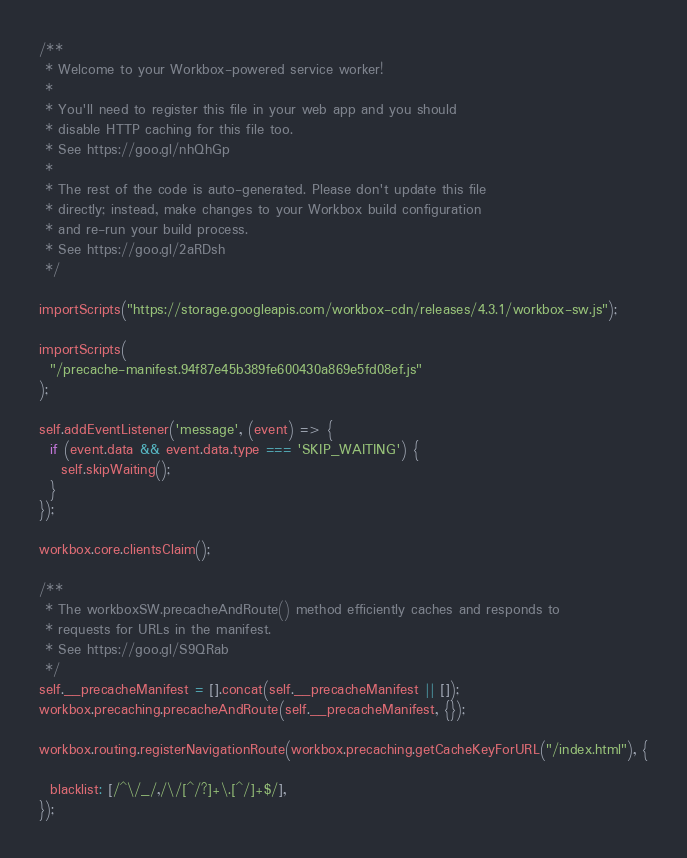<code> <loc_0><loc_0><loc_500><loc_500><_JavaScript_>/**
 * Welcome to your Workbox-powered service worker!
 *
 * You'll need to register this file in your web app and you should
 * disable HTTP caching for this file too.
 * See https://goo.gl/nhQhGp
 *
 * The rest of the code is auto-generated. Please don't update this file
 * directly; instead, make changes to your Workbox build configuration
 * and re-run your build process.
 * See https://goo.gl/2aRDsh
 */

importScripts("https://storage.googleapis.com/workbox-cdn/releases/4.3.1/workbox-sw.js");

importScripts(
  "/precache-manifest.94f87e45b389fe600430a869e5fd08ef.js"
);

self.addEventListener('message', (event) => {
  if (event.data && event.data.type === 'SKIP_WAITING') {
    self.skipWaiting();
  }
});

workbox.core.clientsClaim();

/**
 * The workboxSW.precacheAndRoute() method efficiently caches and responds to
 * requests for URLs in the manifest.
 * See https://goo.gl/S9QRab
 */
self.__precacheManifest = [].concat(self.__precacheManifest || []);
workbox.precaching.precacheAndRoute(self.__precacheManifest, {});

workbox.routing.registerNavigationRoute(workbox.precaching.getCacheKeyForURL("/index.html"), {
  
  blacklist: [/^\/_/,/\/[^/?]+\.[^/]+$/],
});
</code> 